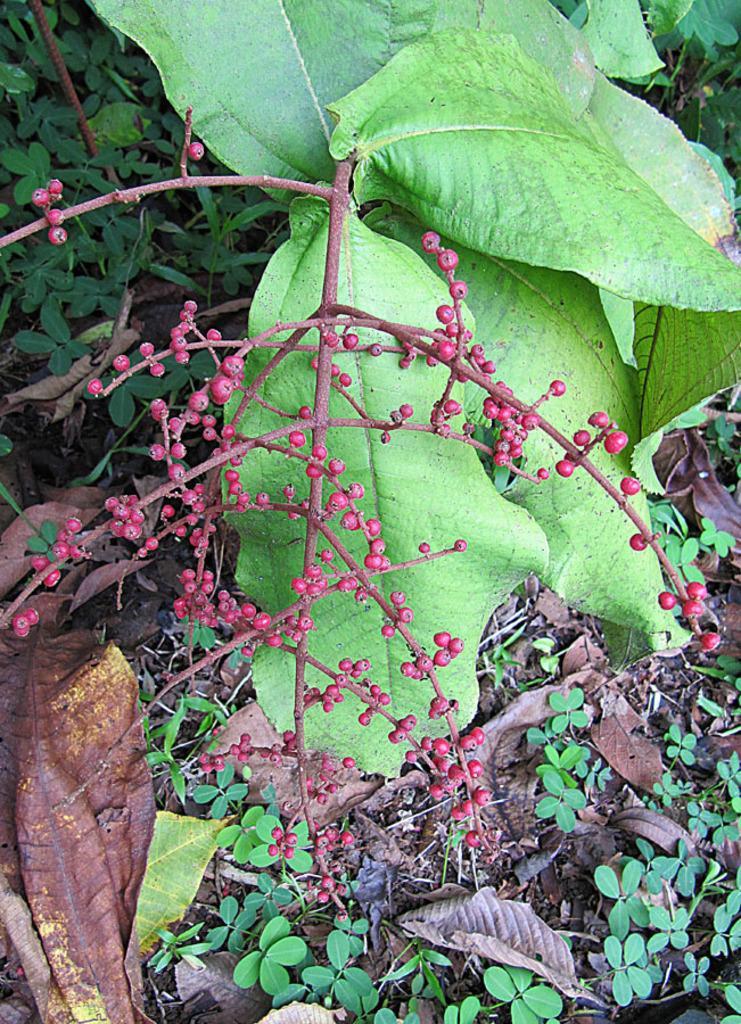What type of living organisms can be seen in the image? Plants can be seen in the image. What part of the plants is visible in the image? Leaves are visible in the image. What is located in the middle of the image? There are fruits in the middle of the image. How many frogs can be seen sitting on the tomatoes in the image? There are no frogs or tomatoes present in the image. 